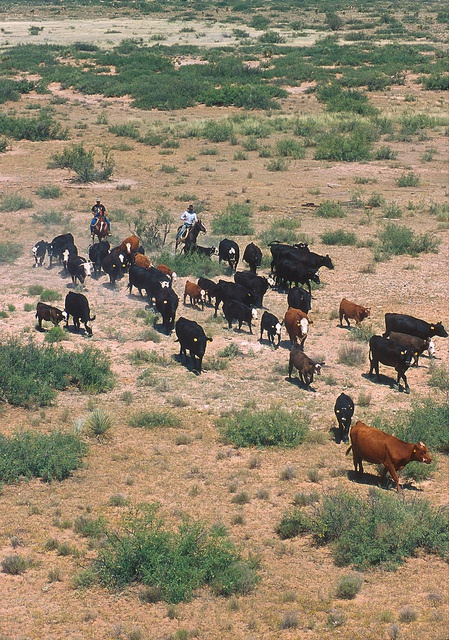Describe the objects in this image and their specific colors. I can see cow in teal, black, gray, and maroon tones, cow in teal, maroon, black, brown, and gray tones, cow in teal, black, gray, and khaki tones, cow in teal, black, and gray tones, and cow in teal, black, gray, and tan tones in this image. 